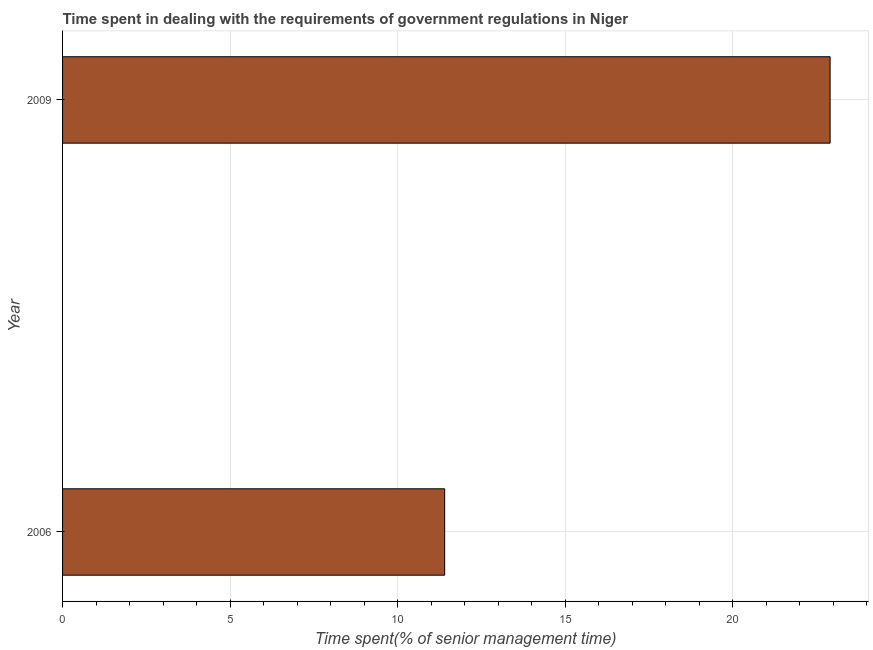Does the graph contain grids?
Provide a short and direct response. Yes. What is the title of the graph?
Offer a terse response. Time spent in dealing with the requirements of government regulations in Niger. What is the label or title of the X-axis?
Give a very brief answer. Time spent(% of senior management time). What is the label or title of the Y-axis?
Your response must be concise. Year. What is the time spent in dealing with government regulations in 2006?
Provide a succinct answer. 11.4. Across all years, what is the maximum time spent in dealing with government regulations?
Give a very brief answer. 22.9. Across all years, what is the minimum time spent in dealing with government regulations?
Your response must be concise. 11.4. What is the sum of the time spent in dealing with government regulations?
Your answer should be compact. 34.3. What is the average time spent in dealing with government regulations per year?
Your answer should be very brief. 17.15. What is the median time spent in dealing with government regulations?
Provide a succinct answer. 17.15. In how many years, is the time spent in dealing with government regulations greater than 1 %?
Your answer should be very brief. 2. What is the ratio of the time spent in dealing with government regulations in 2006 to that in 2009?
Provide a succinct answer. 0.5. In how many years, is the time spent in dealing with government regulations greater than the average time spent in dealing with government regulations taken over all years?
Give a very brief answer. 1. How many bars are there?
Offer a terse response. 2. What is the Time spent(% of senior management time) of 2006?
Provide a short and direct response. 11.4. What is the Time spent(% of senior management time) of 2009?
Offer a very short reply. 22.9. What is the ratio of the Time spent(% of senior management time) in 2006 to that in 2009?
Provide a succinct answer. 0.5. 